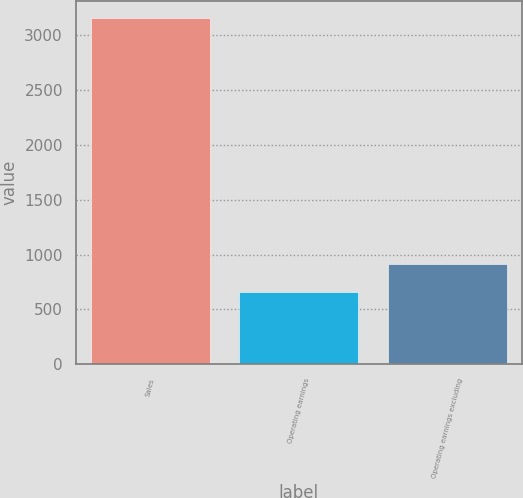Convert chart to OTSL. <chart><loc_0><loc_0><loc_500><loc_500><bar_chart><fcel>Sales<fcel>Operating earnings<fcel>Operating earnings excluding<nl><fcel>3159<fcel>660<fcel>909.9<nl></chart> 